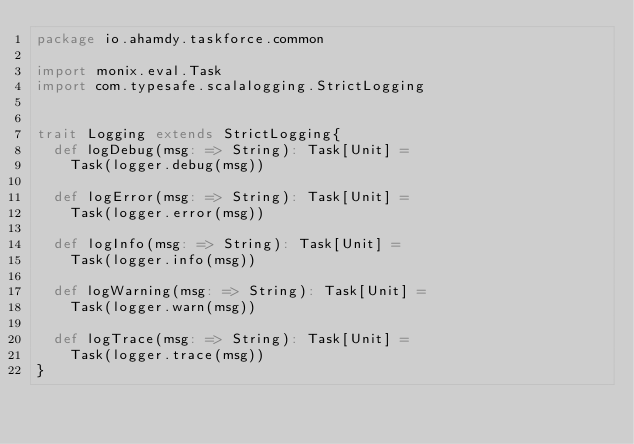<code> <loc_0><loc_0><loc_500><loc_500><_Scala_>package io.ahamdy.taskforce.common

import monix.eval.Task
import com.typesafe.scalalogging.StrictLogging


trait Logging extends StrictLogging{
  def logDebug(msg: => String): Task[Unit] =
    Task(logger.debug(msg))

  def logError(msg: => String): Task[Unit] =
    Task(logger.error(msg))

  def logInfo(msg: => String): Task[Unit] =
    Task(logger.info(msg))

  def logWarning(msg: => String): Task[Unit] =
    Task(logger.warn(msg))

  def logTrace(msg: => String): Task[Unit] =
    Task(logger.trace(msg))
}
</code> 